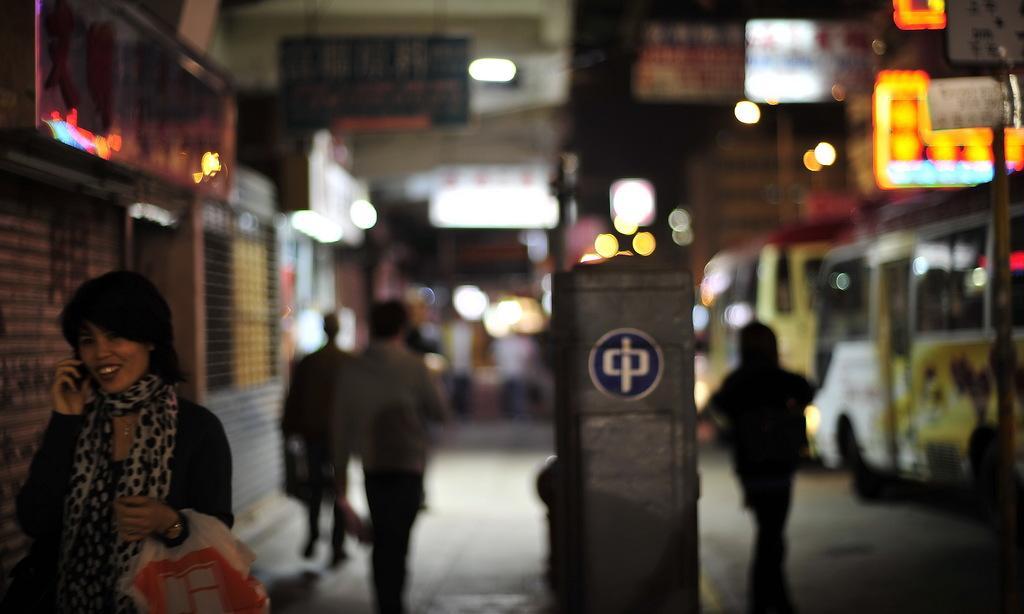Please provide a concise description of this image. This image is taken during the night time. In this image we can see people walking on the road. In the center there is a pillar. Image also consists of buildings, vehicles and also the lights. 